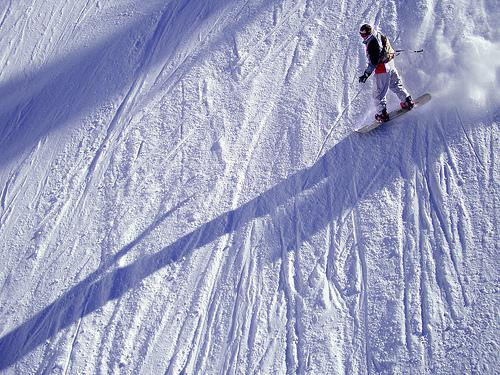Question: who is in the picture?
Choices:
A. A man.
B. Family.
C. Dog.
D. Woman.
Answer with the letter. Answer: A Question: how many people are in the picture?
Choices:
A. Two.
B. Three.
C. One.
D. Four.
Answer with the letter. Answer: C Question: what is the man doing?
Choices:
A. Painting.
B. Sleeping.
C. Snowboarding.
D. Jogging.
Answer with the letter. Answer: C Question: what is covering the ground?
Choices:
A. Water.
B. Mud.
C. Snow.
D. Lava.
Answer with the letter. Answer: C Question: what color is the snow?
Choices:
A. Brown.
B. Yellow.
C. Cream.
D. White.
Answer with the letter. Answer: D Question: what does the man have covering his eyes?
Choices:
A. His hands.
B. A hat.
C. Goggles.
D. His hair.
Answer with the letter. Answer: C 